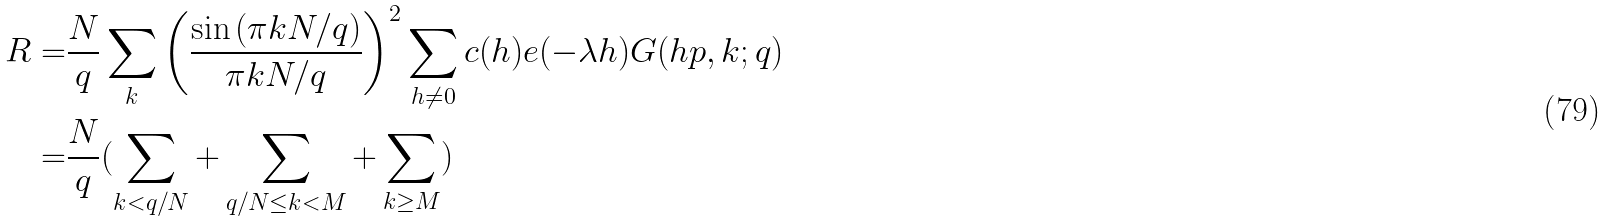Convert formula to latex. <formula><loc_0><loc_0><loc_500><loc_500>R = & \frac { N } { q } \sum _ { k } \left ( \frac { \sin { ( \pi k N / q ) } } { \pi k N / q } \right ) ^ { 2 } \sum _ { h \neq 0 } c ( h ) e ( - \lambda h ) G ( h p , k ; q ) \\ = & \frac { N } { q } ( \sum _ { k < q / N } + \sum _ { q / N \leq k < M } + \sum _ { k \geq M } )</formula> 